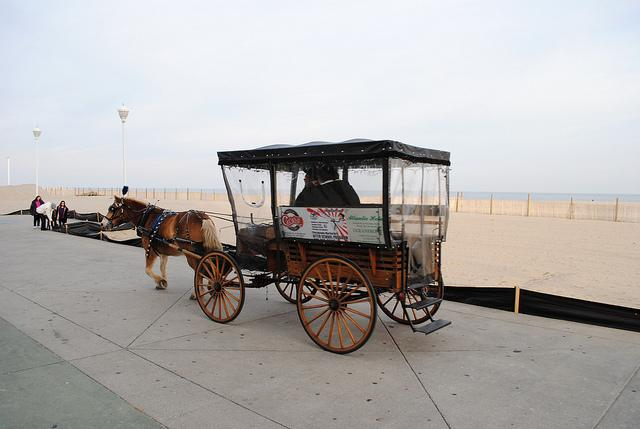What is near the sidewalk here? Please explain your reasoning. beach. This is on the coast 